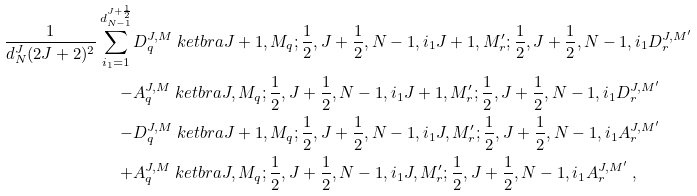<formula> <loc_0><loc_0><loc_500><loc_500>\frac { 1 } { d ^ { J } _ { N } ( 2 J + 2 ) ^ { 2 } } \sum _ { i _ { 1 } = 1 } ^ { d ^ { J + \frac { 1 } { 2 } } _ { N - 1 } } & D _ { q } ^ { J , M } \ k e t b r a { J + 1 , M _ { q } ; \frac { 1 } { 2 } , J + \frac { 1 } { 2 } , N - 1 , i _ { 1 } } { J + 1 , M ^ { \prime } _ { r } ; \frac { 1 } { 2 } , J + \frac { 1 } { 2 } , N - 1 , i _ { 1 } } D _ { r } ^ { J , M ^ { \prime } } \\ - & A _ { q } ^ { J , M } \ k e t b r a { J , M _ { q } ; \frac { 1 } { 2 } , J + \frac { 1 } { 2 } , N - 1 , i _ { 1 } } { J + 1 , M ^ { \prime } _ { r } ; \frac { 1 } { 2 } , J + \frac { 1 } { 2 } , N - 1 , i _ { 1 } } D _ { r } ^ { J , M ^ { \prime } } \\ - & D _ { q } ^ { J , M } \ k e t b r a { J + 1 , M _ { q } ; \frac { 1 } { 2 } , J + \frac { 1 } { 2 } , N - 1 , i _ { 1 } } { J , M ^ { \prime } _ { r } ; \frac { 1 } { 2 } , J + \frac { 1 } { 2 } , N - 1 , i _ { 1 } } A _ { r } ^ { J , M ^ { \prime } } \\ + & A _ { q } ^ { J , M } \ k e t b r a { J , M _ { q } ; \frac { 1 } { 2 } , J + \frac { 1 } { 2 } , N - 1 , i _ { 1 } } { J , M ^ { \prime } _ { r } ; \frac { 1 } { 2 } , J + \frac { 1 } { 2 } , N - 1 , i _ { 1 } } A _ { r } ^ { J , M ^ { \prime } } \ ,</formula> 